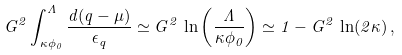<formula> <loc_0><loc_0><loc_500><loc_500>G ^ { 2 } \int _ { \kappa \phi _ { 0 } } ^ { \Lambda } \frac { d ( q - \mu ) } { \epsilon _ { q } } \simeq G ^ { 2 } \, \ln \left ( \frac { \Lambda } { \kappa \phi _ { 0 } } \right ) \simeq 1 - G ^ { 2 } \, \ln ( 2 \kappa ) \, ,</formula> 